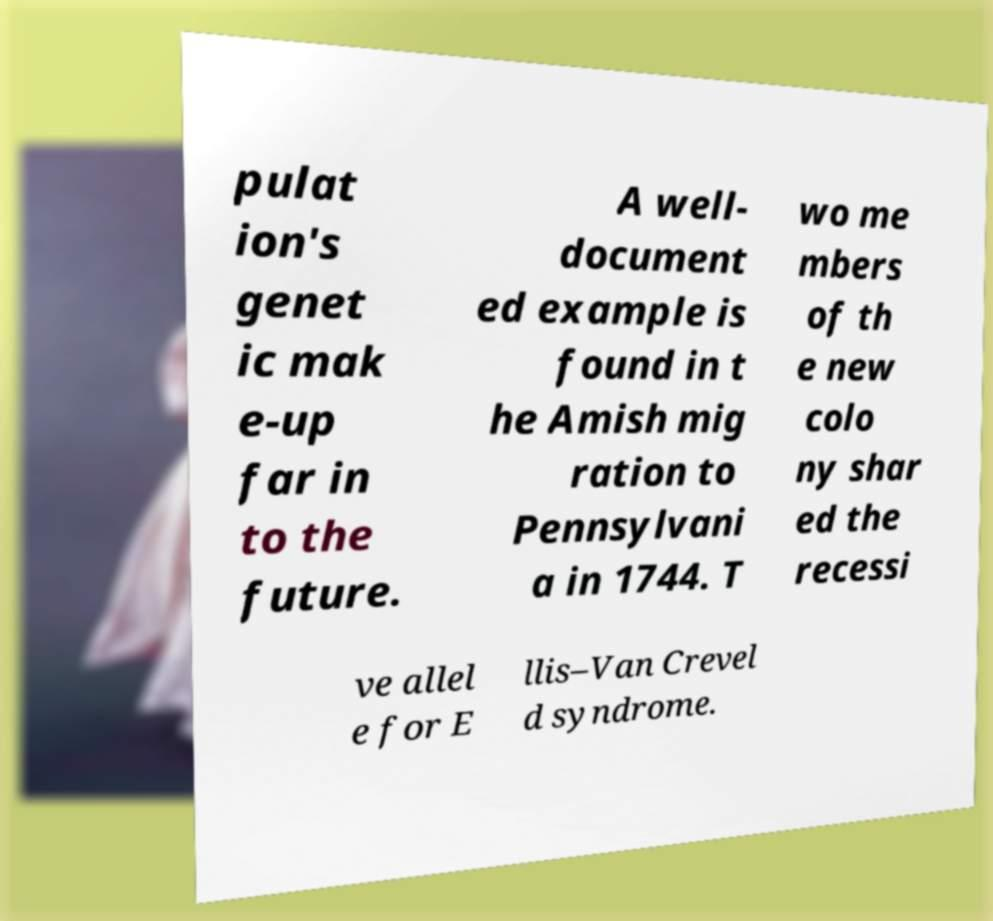Could you assist in decoding the text presented in this image and type it out clearly? pulat ion's genet ic mak e-up far in to the future. A well- document ed example is found in t he Amish mig ration to Pennsylvani a in 1744. T wo me mbers of th e new colo ny shar ed the recessi ve allel e for E llis–Van Crevel d syndrome. 